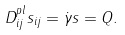<formula> <loc_0><loc_0><loc_500><loc_500>D _ { i j } ^ { p l } s _ { i j } = \dot { \gamma } s = Q .</formula> 